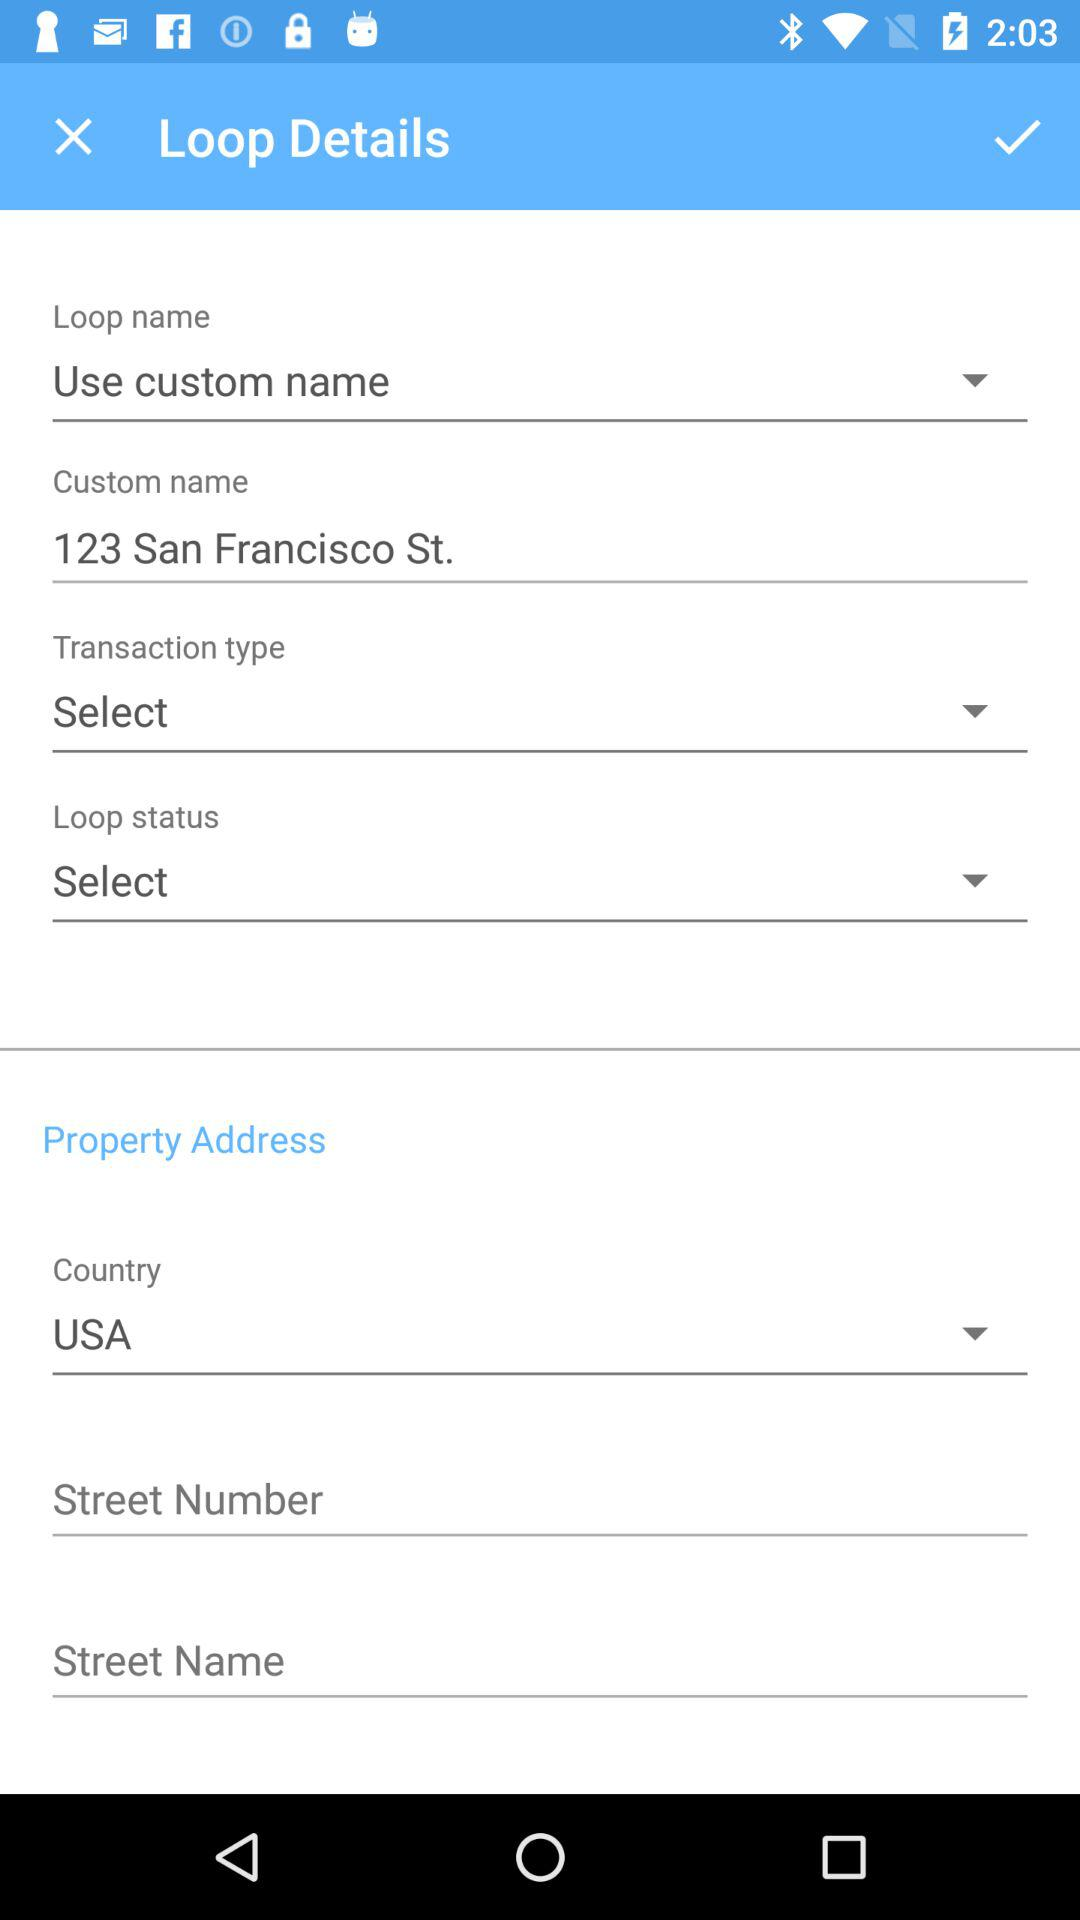Which loop name is selected? The selected loop name is "Use custom name". 